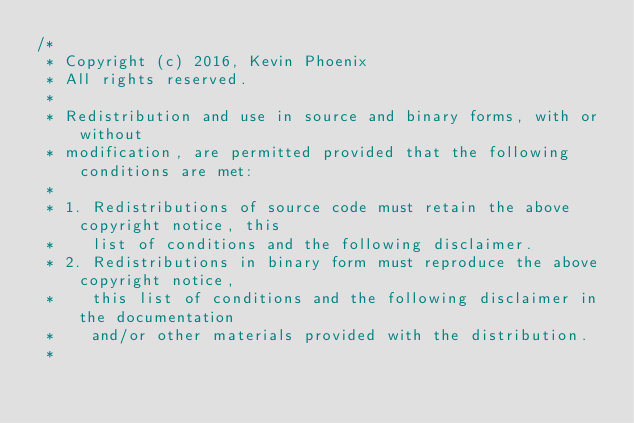Convert code to text. <code><loc_0><loc_0><loc_500><loc_500><_Java_>/*
 * Copyright (c) 2016, Kevin Phoenix
 * All rights reserved.
 *
 * Redistribution and use in source and binary forms, with or without
 * modification, are permitted provided that the following conditions are met:
 *
 * 1. Redistributions of source code must retain the above copyright notice, this
 *    list of conditions and the following disclaimer.
 * 2. Redistributions in binary form must reproduce the above copyright notice,
 *    this list of conditions and the following disclaimer in the documentation
 *    and/or other materials provided with the distribution.
 *</code> 